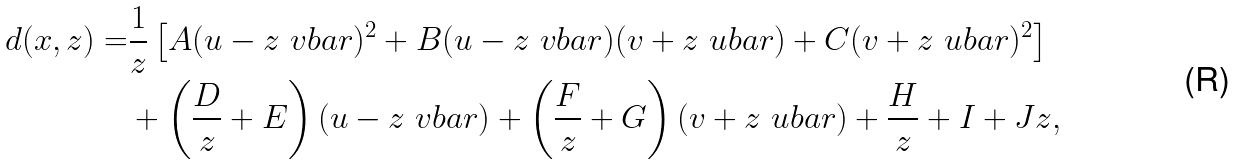Convert formula to latex. <formula><loc_0><loc_0><loc_500><loc_500>d ( x , z ) = & \frac { 1 } { z } \left [ A ( u - z { \ v b a r } ) ^ { 2 } + B ( u - z { \ v b a r } ) ( v + z { \ u b a r } ) + C ( v + z { \ u b a r } ) ^ { 2 } \right ] \\ & + \left ( \frac { D } { z } + E \right ) ( u - z { \ v b a r } ) + \left ( \frac { F } { z } + G \right ) ( v + z { \ u b a r } ) + \frac { H } { z } + I + J z ,</formula> 